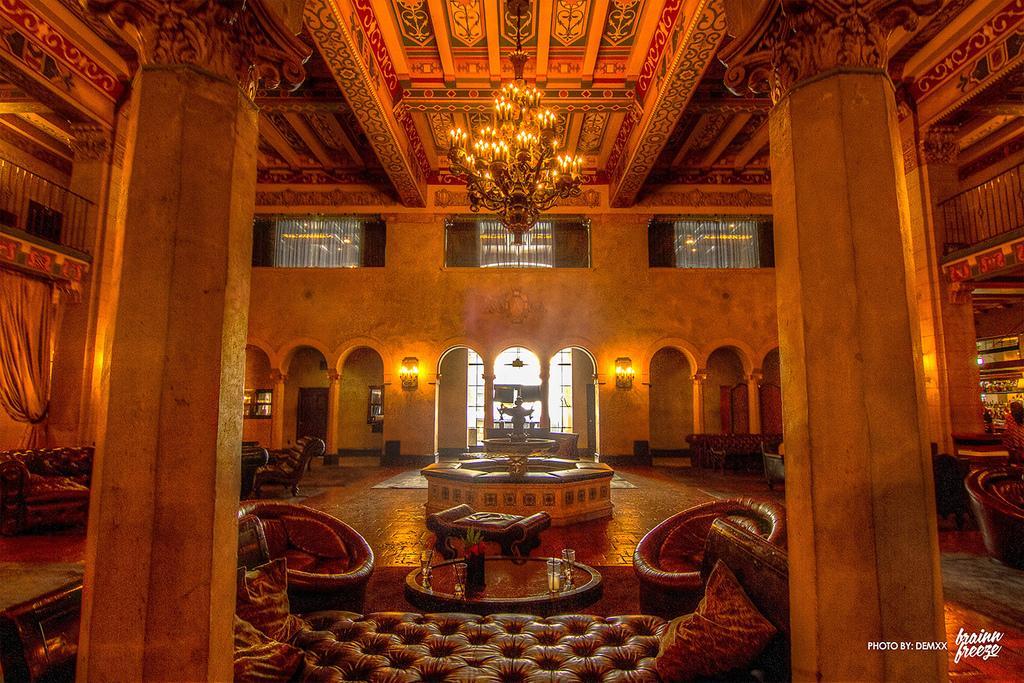Could you give a brief overview of what you see in this image? In this image we can see the inner view of the building with some furniture and we can see some objects like chairs, sofas and tables. We can see a statue like structure in the middle of the image and there are some lights attached to the walls and we can see the chandelier attached to the ceiling. 